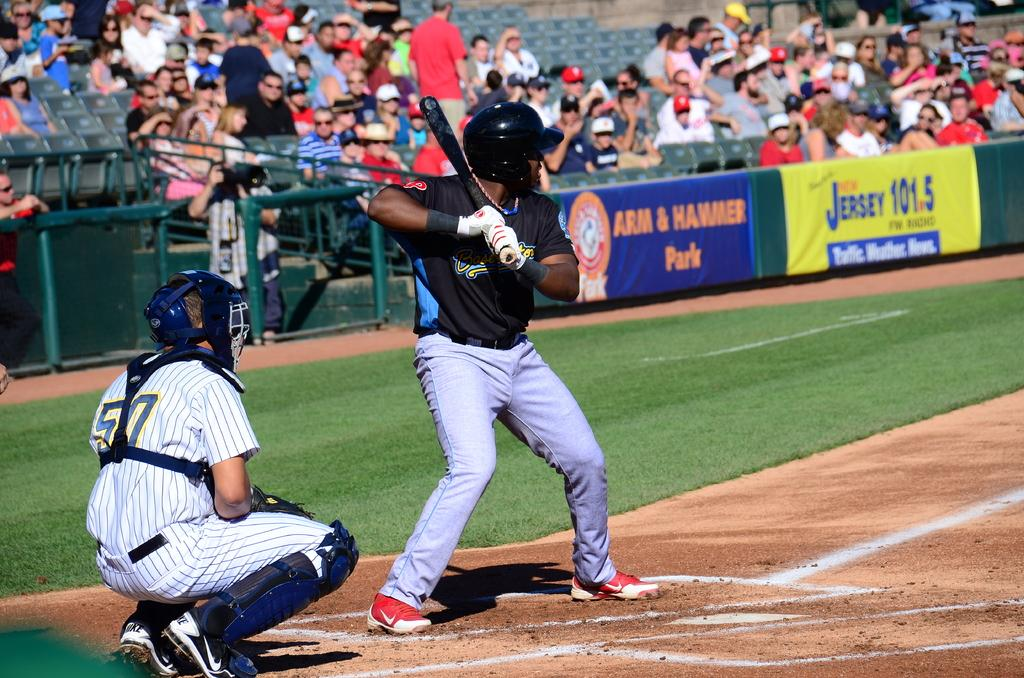<image>
Give a short and clear explanation of the subsequent image. A baseball player up at bat at Arm & Hammer Park in Jersey. 